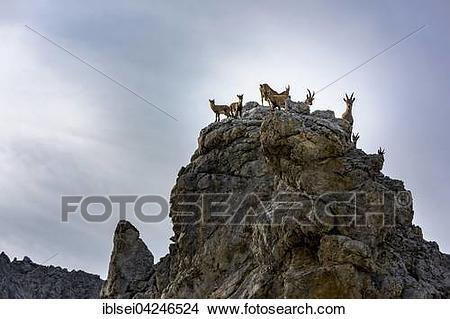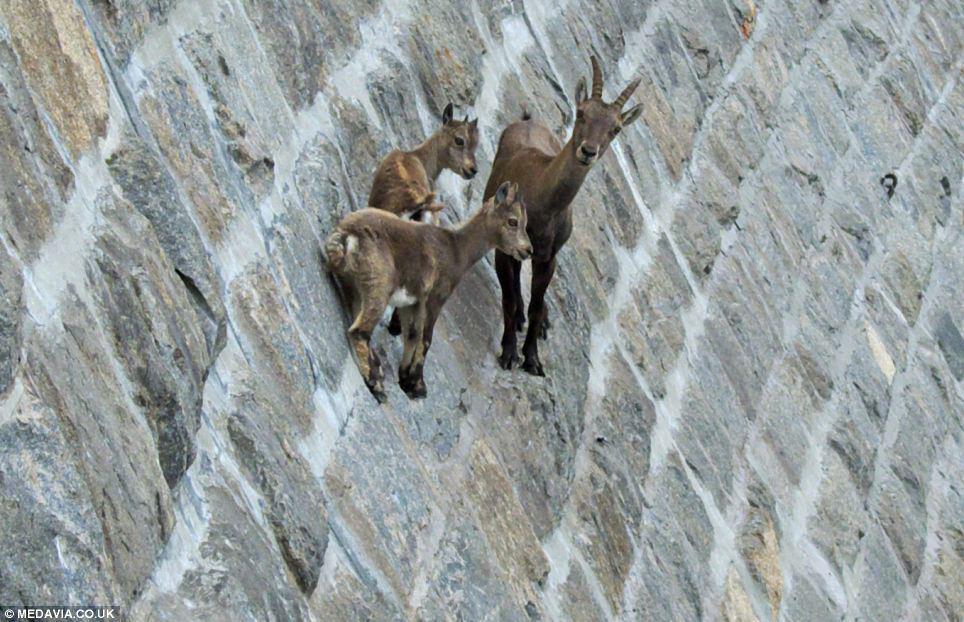The first image is the image on the left, the second image is the image on the right. Given the left and right images, does the statement "An image shows multiple horned animals standing atop a rocky peak." hold true? Answer yes or no. Yes. 